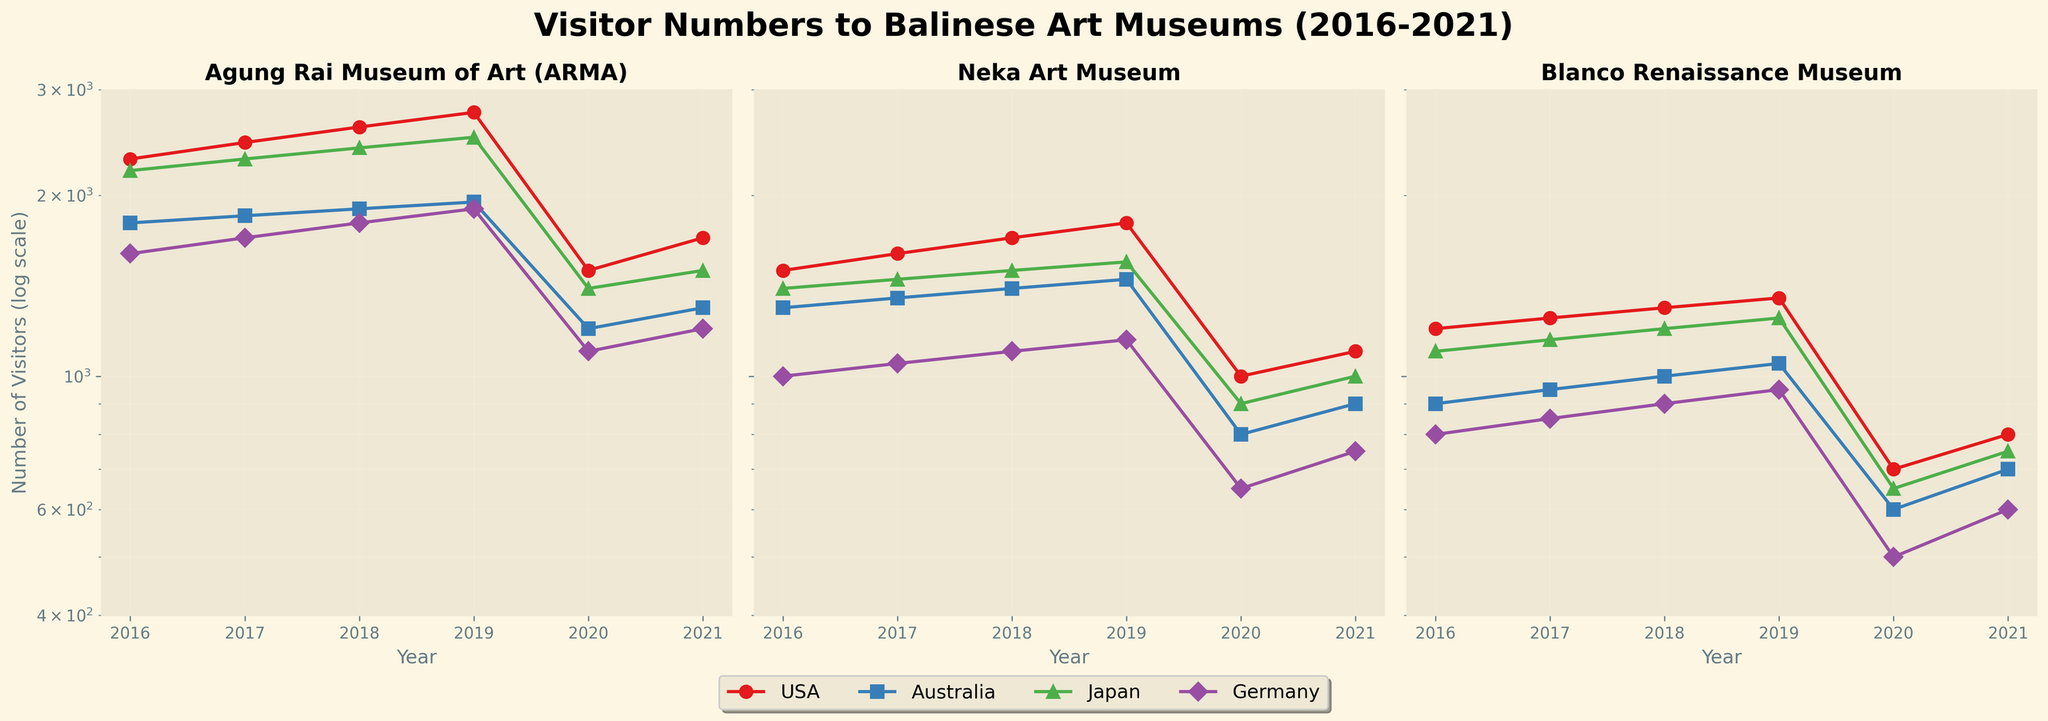Which museum had the highest number of visitors from the USA in 2019? To determine which museum had the highest number of visitors in 2019 from the USA, observe the plotted points for the year 2019 in the USA's data series. The highest value corresponds to the Agung Rai Museum of Art (ARMA) with 2750 visitors.
Answer: Agung Rai Museum of Art (ARMA) What trend is observed for Japanese visitors at the Blanco Renaissance Museum from 2016-2021? Observing the plot for the Blanco Renaissance Museum, notice that visitors from Japan increased from 2016 to 2019, then sharply decreased in 2020, and slightly increased in 2021.
Answer: Increased then decreased Which country had the fewest visitors to the Neka Art Museum in 2020? The plot for the Neka Art Museum shows that in 2020, Germany had the fewest visitors compared to other countries, with about 650 visitors.
Answer: Germany How did the visitor numbers from Australia to the Agung Rai Museum of Art (ARMA) change from 2018 to 2020? For Australia at the Agung Rai Museum of Art (ARMA), the number of visitors increased from 1900 in 2018 to 1950 in 2019, then dropped to 1200 in 2020.
Answer: Increased then decreased Compare the change in visitor numbers from Germany to the Blanco Renaissance Museum and the Agung Rai Museum of Art (ARMA) between 2019 and 2020. For the Blanco Renaissance Museum, Germany's visitors dropped from 950 to 500 between 2019 and 2020. For the Agung Rai Museum of Art (ARMA), the numbers dropped from 1900 to 1100. Both values decreased, but the drop for the Agung Rai Museum of Art (ARMA) was more significant (800 vs. 450).
Answer: ARMA (more significant drop) Which year had a noticeable decline in visitors across all countries for the Neka Art Museum? The log scale plot for the Neka Art Museum shows a marked decline in visitor numbers across all countries in the year 2020.
Answer: 2020 What is the range of visitor numbers observed for the USA across all museums in the year 2021? For the year 2021, visitors from the USA are around 1700 for the Agung Rai Museum of Art (ARMA), 1100 for the Neka Art Museum, and 800 for the Blanco Renaissance Museum. The range is 1700 - 800 = 900.
Answer: 900 Identify a year where Agung Rai Museum of Art (ARMA) had both an increase and decrease in visitor numbers, based on the country. In 2020, the Agung Rai Museum of Art (ARMA) saw an increase in visitors from Japan (from 1400 in 2019 to 1500) while witnessing a decrease in visitors from the USA, Australia, and Germany.
Answer: 2020 